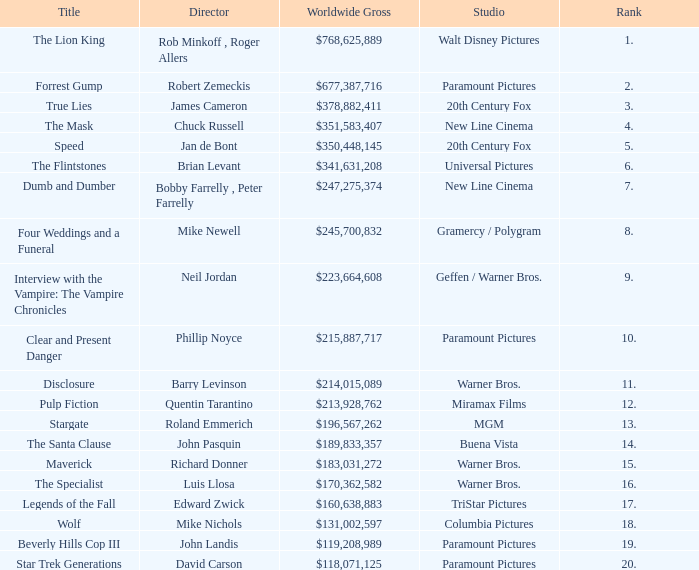What is the Title of the Film with a Rank greater than 11 and Worldwide Gross of $131,002,597? Wolf. 